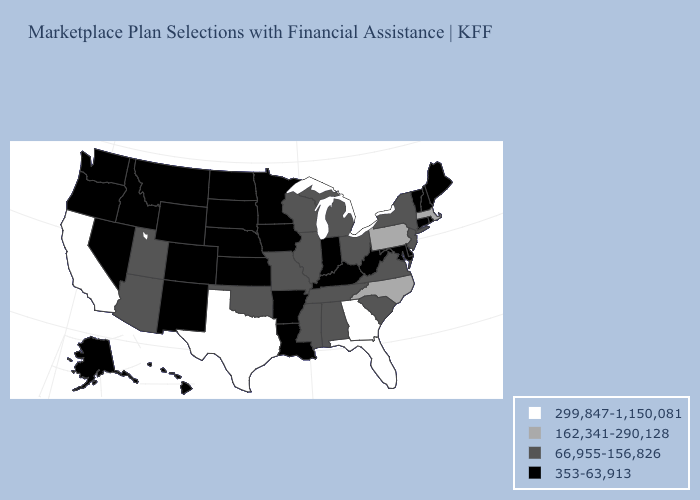Which states hav the highest value in the South?
Quick response, please. Florida, Georgia, Texas. Name the states that have a value in the range 66,955-156,826?
Short answer required. Alabama, Arizona, Illinois, Michigan, Mississippi, Missouri, New Jersey, New York, Ohio, Oklahoma, South Carolina, Tennessee, Utah, Virginia, Wisconsin. Name the states that have a value in the range 162,341-290,128?
Keep it brief. Massachusetts, North Carolina, Pennsylvania. What is the highest value in the USA?
Concise answer only. 299,847-1,150,081. Which states hav the highest value in the MidWest?
Write a very short answer. Illinois, Michigan, Missouri, Ohio, Wisconsin. Among the states that border New York , which have the lowest value?
Keep it brief. Connecticut, Vermont. What is the value of California?
Answer briefly. 299,847-1,150,081. Does Georgia have the highest value in the USA?
Be succinct. Yes. Does the map have missing data?
Write a very short answer. No. Does Virginia have a lower value than Florida?
Concise answer only. Yes. Does Connecticut have the highest value in the USA?
Quick response, please. No. Does Massachusetts have the highest value in the USA?
Give a very brief answer. No. Does Missouri have a higher value than New Hampshire?
Be succinct. Yes. Does Rhode Island have the highest value in the Northeast?
Be succinct. No. What is the highest value in the South ?
Be succinct. 299,847-1,150,081. 